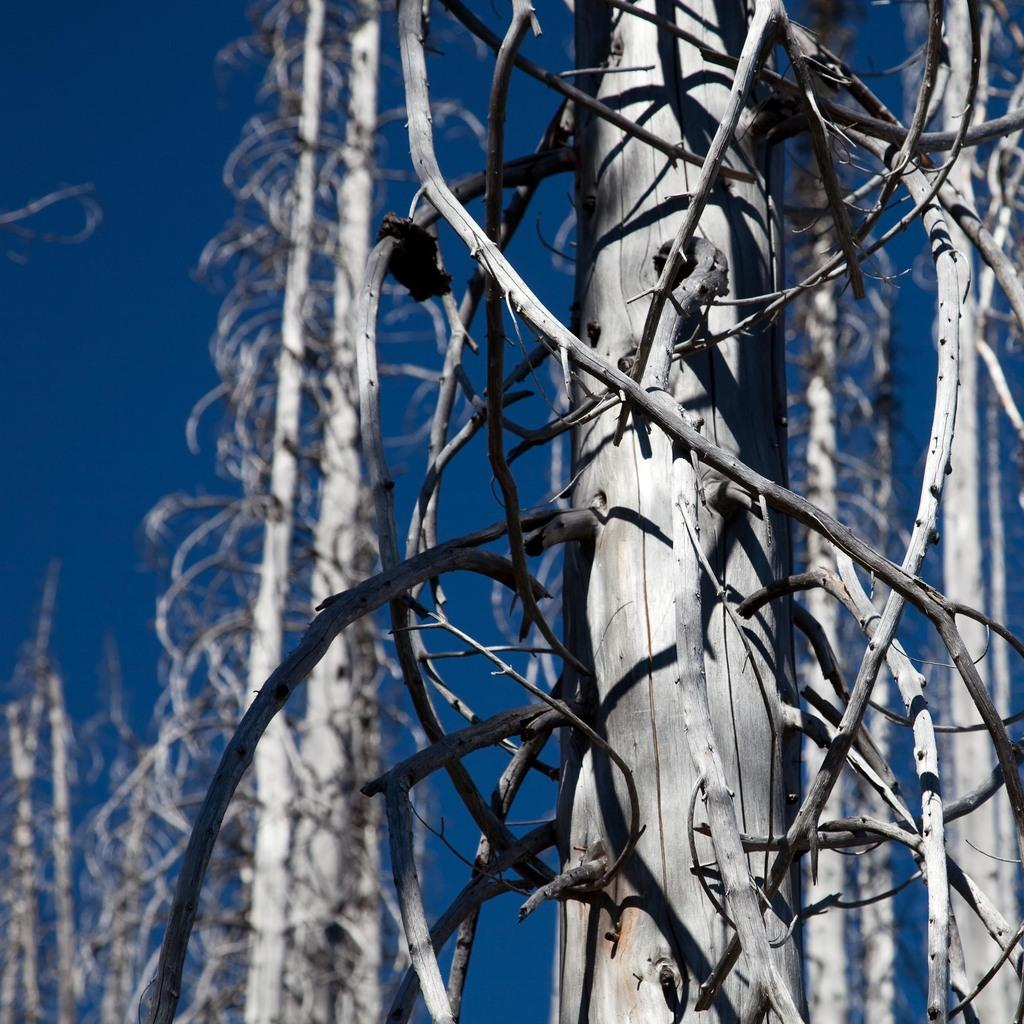What type of plant can be seen in the image? There is a tree in the image. What part of the tree is visible in the image? There are dried branches of a tree in the image. What is visible at the top of the image? The sky is visible at the top of the image. What is the color of the sky in the image? The color of the sky is blue. What sound does the ladybug make in the image? There is no ladybug present in the image, so it is not possible to determine the sound it might make. 